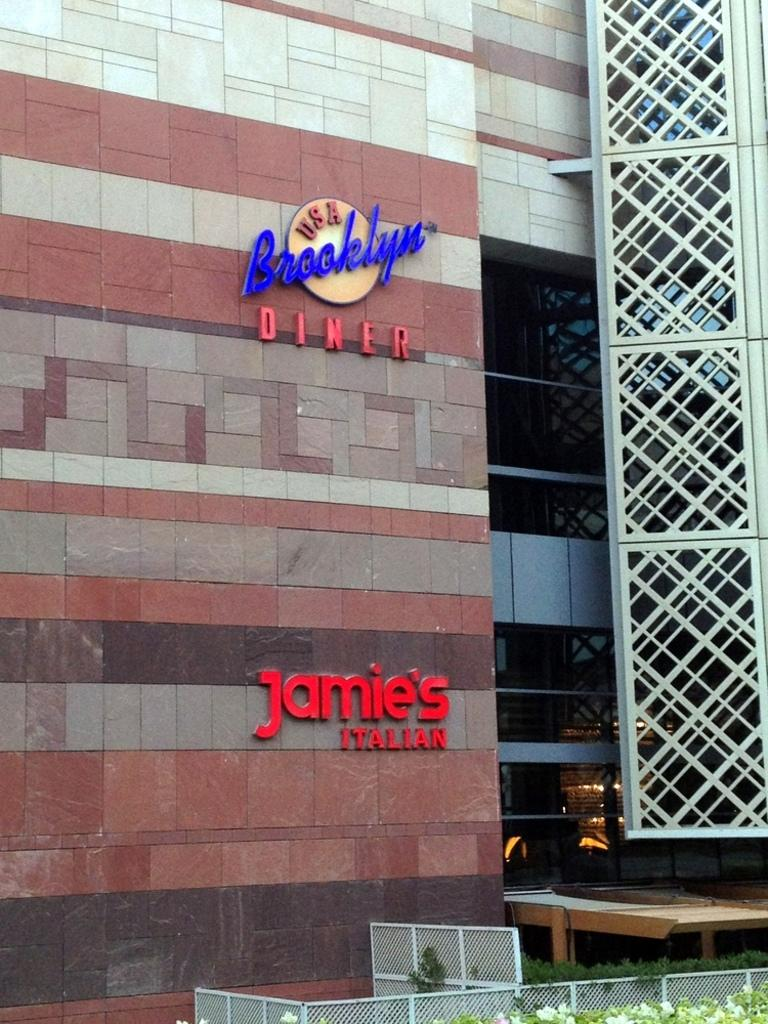What type of structure is visible in the image? There is a building in the image. What is located at the bottom of the image? There is a fence and plants at the bottom of the image. How many rabbits can be seen playing with the wire in the image? There are no rabbits or wire present in the image. What type of laborer is working on the building in the image? There are no laborers visible in the image; it only shows the building, fence, and plants. 